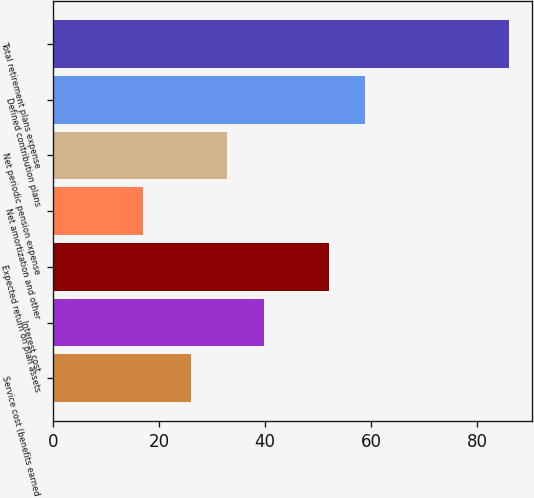<chart> <loc_0><loc_0><loc_500><loc_500><bar_chart><fcel>Service cost (benefits earned<fcel>Interest cost<fcel>Expected return on plan assets<fcel>Net amortization and other<fcel>Net periodic pension expense<fcel>Defined contribution plans<fcel>Total retirement plans expense<nl><fcel>26<fcel>39.8<fcel>52<fcel>17<fcel>32.9<fcel>58.9<fcel>86<nl></chart> 